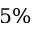<formula> <loc_0><loc_0><loc_500><loc_500>5 \%</formula> 